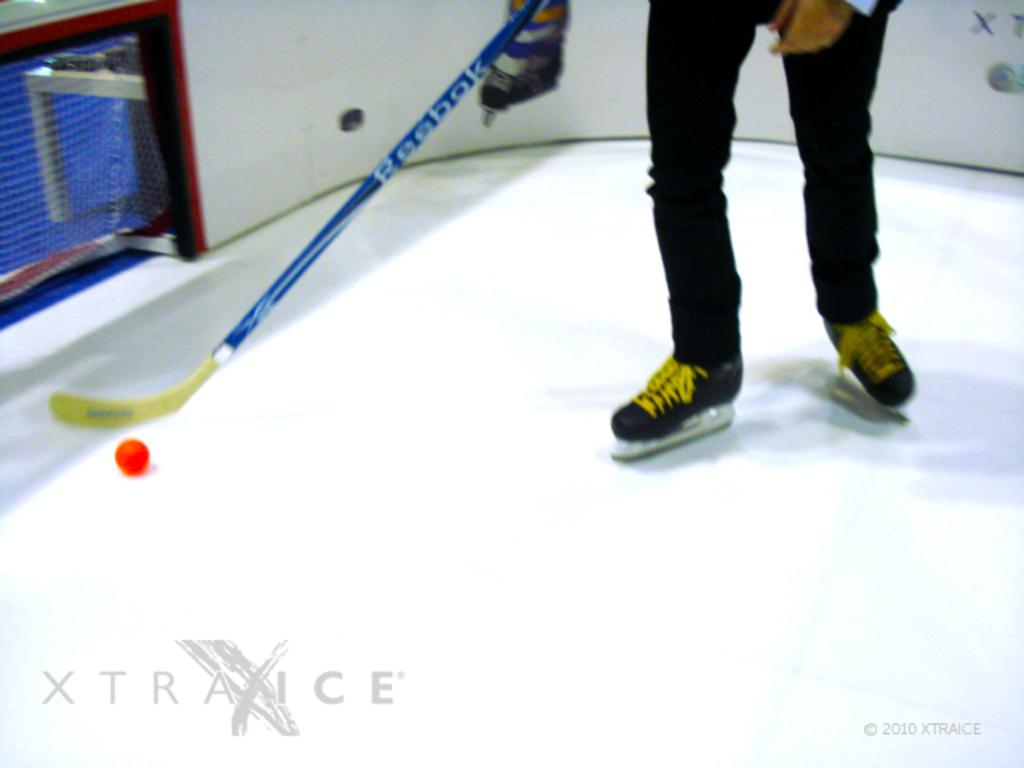What is the person in the image holding? The person is holding a hockey stick. What is on the surface in the image? There is a red color ball on the surface. What can be seen in the background of the image? There is a white color wall and a net in the background. What type of fork is being used to recite a verse in the image? There is no fork or verse present in the image; it features a person holding a hockey stick and a red ball on the surface. Is there a whip visible in the image? No, there is no whip present in the image. 